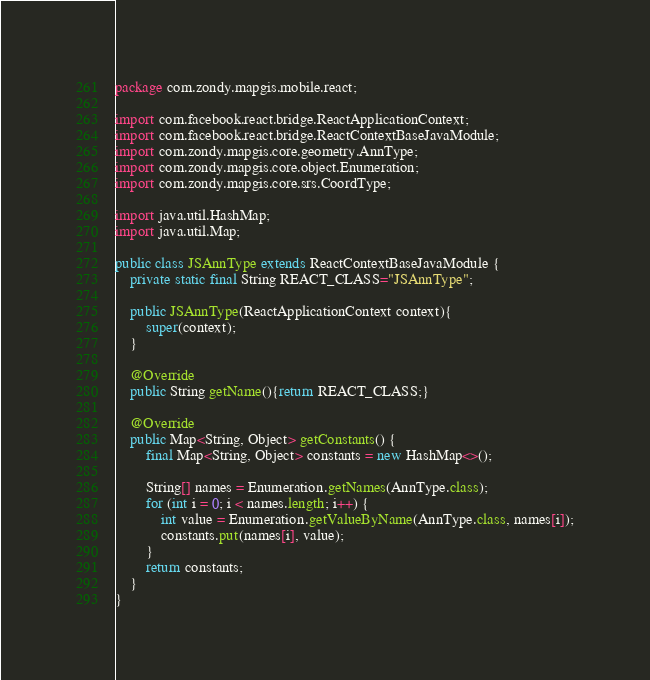Convert code to text. <code><loc_0><loc_0><loc_500><loc_500><_Java_>package com.zondy.mapgis.mobile.react;

import com.facebook.react.bridge.ReactApplicationContext;
import com.facebook.react.bridge.ReactContextBaseJavaModule;
import com.zondy.mapgis.core.geometry.AnnType;
import com.zondy.mapgis.core.object.Enumeration;
import com.zondy.mapgis.core.srs.CoordType;

import java.util.HashMap;
import java.util.Map;

public class JSAnnType extends ReactContextBaseJavaModule {
    private static final String REACT_CLASS="JSAnnType";

    public JSAnnType(ReactApplicationContext context){
        super(context);
    }

    @Override
    public String getName(){return REACT_CLASS;}

    @Override
    public Map<String, Object> getConstants() {
        final Map<String, Object> constants = new HashMap<>();

        String[] names = Enumeration.getNames(AnnType.class);
        for (int i = 0; i < names.length; i++) {
            int value = Enumeration.getValueByName(AnnType.class, names[i]);
            constants.put(names[i], value);
        }
        return constants;
    }
}
</code> 